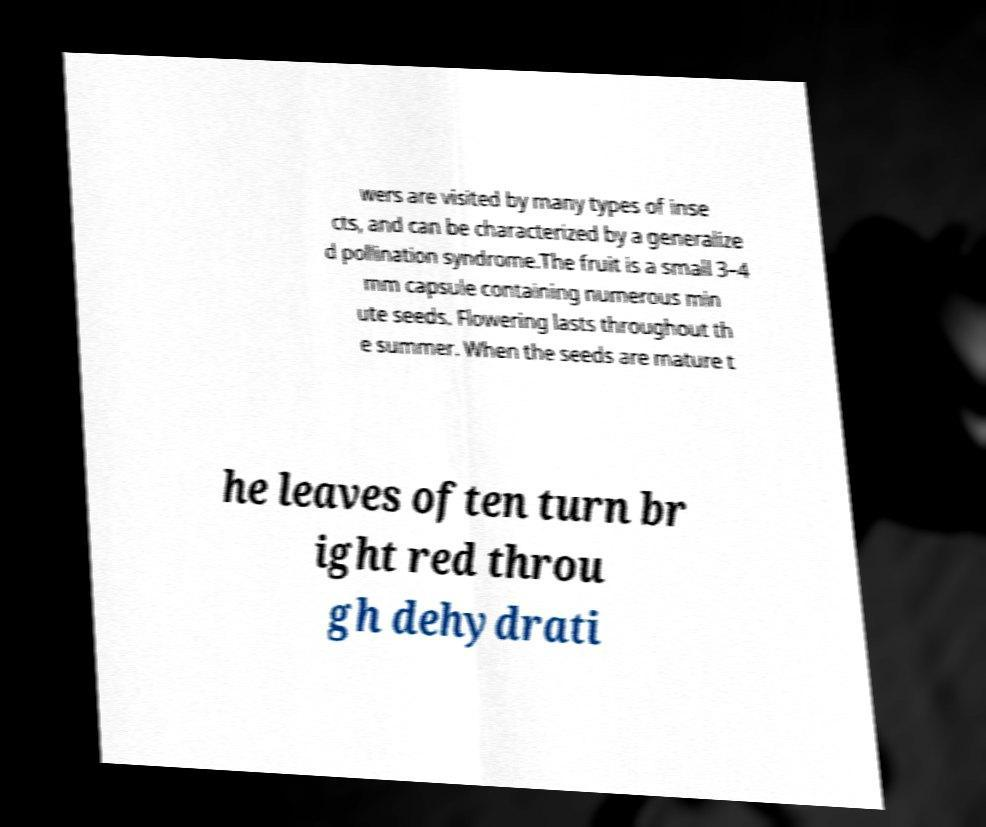For documentation purposes, I need the text within this image transcribed. Could you provide that? wers are visited by many types of inse cts, and can be characterized by a generalize d pollination syndrome.The fruit is a small 3–4 mm capsule containing numerous min ute seeds. Flowering lasts throughout th e summer. When the seeds are mature t he leaves often turn br ight red throu gh dehydrati 